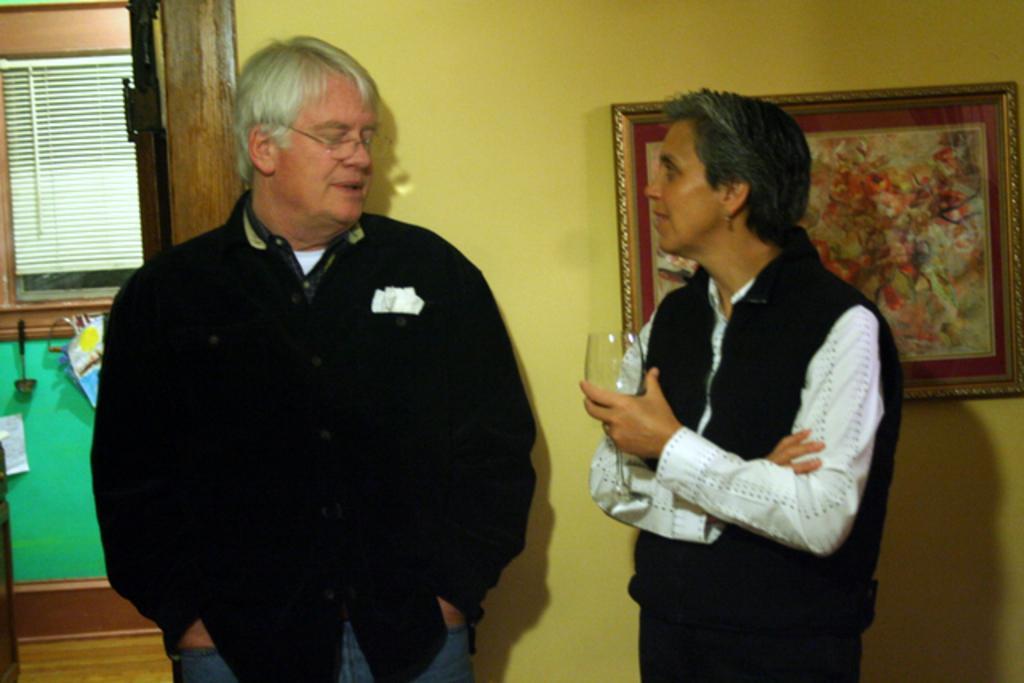Describe this image in one or two sentences. In the image two persons are standing and she is holding a glass. Behind them there is a wall, on the wall there is a frame. 